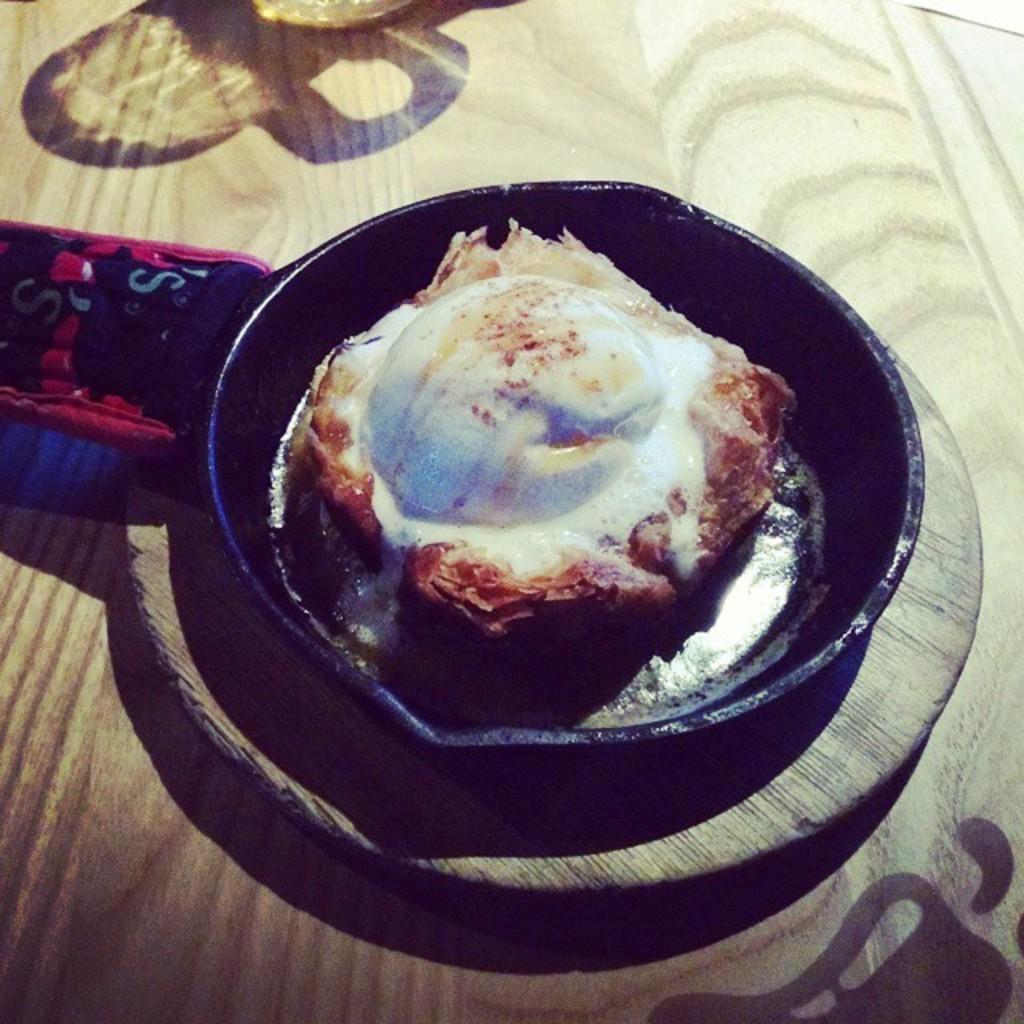Could you give a brief overview of what you see in this image? This is a zoomed in picture. In the center there is a wooden object on the top of which a pan containing food item is placed. In the background there is another object seems to be the table. 